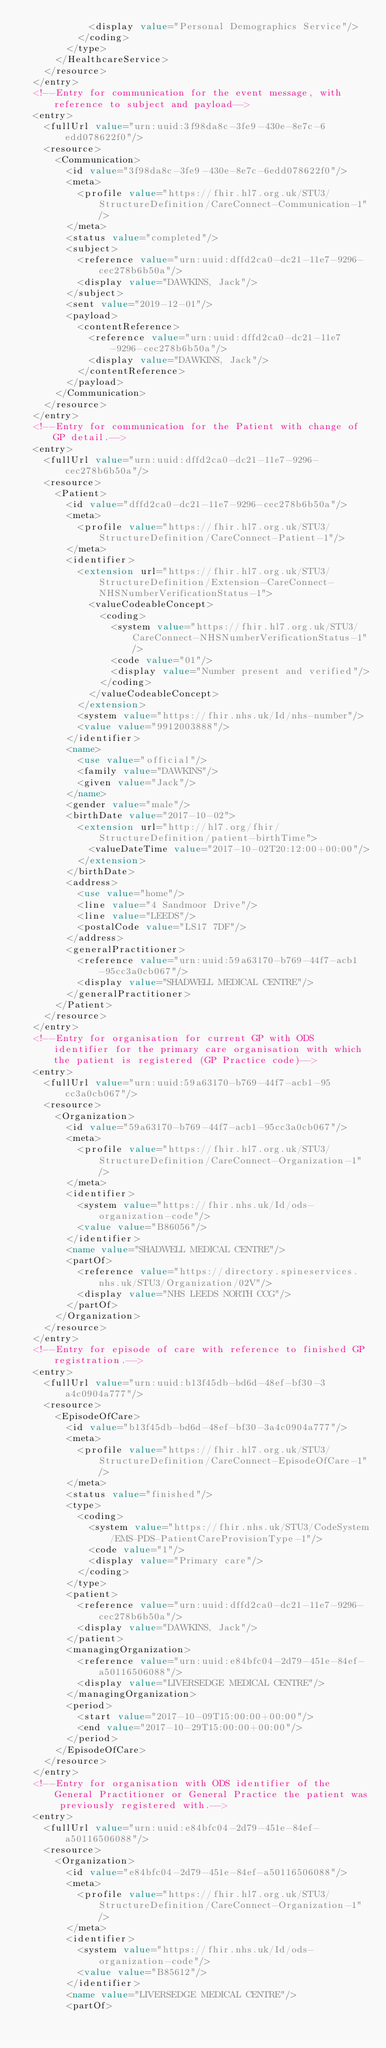Convert code to text. <code><loc_0><loc_0><loc_500><loc_500><_XML_>						<display value="Personal Demographics Service"/>
					</coding>
				</type>
			</HealthcareService>
		</resource>
	</entry>
	<!--Entry for communication for the event message, with reference to subject and payload-->
	<entry>
		<fullUrl value="urn:uuid:3f98da8c-3fe9-430e-8e7c-6edd078622f0"/>
		<resource>
			<Communication>
				<id value="3f98da8c-3fe9-430e-8e7c-6edd078622f0"/>
				<meta>
					<profile value="https://fhir.hl7.org.uk/STU3/StructureDefinition/CareConnect-Communication-1"/>
				</meta>
				<status value="completed"/>
				<subject>
					<reference value="urn:uuid:dffd2ca0-dc21-11e7-9296-cec278b6b50a"/>
					<display value="DAWKINS, Jack"/>
				</subject>
				<sent value="2019-12-01"/>
				<payload>
					<contentReference>
						<reference value="urn:uuid:dffd2ca0-dc21-11e7-9296-cec278b6b50a"/>
						<display value="DAWKINS, Jack"/>
					</contentReference>
				</payload>
			</Communication>
		</resource>
	</entry>
	<!--Entry for communication for the Patient with change of GP detail.-->
	<entry>
		<fullUrl value="urn:uuid:dffd2ca0-dc21-11e7-9296-cec278b6b50a"/>
		<resource>
			<Patient>
				<id value="dffd2ca0-dc21-11e7-9296-cec278b6b50a"/>
				<meta>
					<profile value="https://fhir.hl7.org.uk/STU3/StructureDefinition/CareConnect-Patient-1"/>
				</meta>
				<identifier>
					<extension url="https://fhir.hl7.org.uk/STU3/StructureDefinition/Extension-CareConnect-NHSNumberVerificationStatus-1">
						<valueCodeableConcept>
							<coding>
								<system value="https://fhir.hl7.org.uk/STU3/CareConnect-NHSNumberVerificationStatus-1"/>
								<code value="01"/>
								<display value="Number present and verified"/>
							</coding>
						</valueCodeableConcept>
					</extension>
					<system value="https://fhir.nhs.uk/Id/nhs-number"/>
					<value value="9912003888"/>
				</identifier>
				<name>
					<use value="official"/>
					<family value="DAWKINS"/>
					<given value="Jack"/>
				</name>
				<gender value="male"/>
				<birthDate value="2017-10-02">
					<extension url="http://hl7.org/fhir/StructureDefinition/patient-birthTime">
						<valueDateTime value="2017-10-02T20:12:00+00:00"/>
					</extension>
				</birthDate>
				<address>
					<use value="home"/>
					<line value="4 Sandmoor Drive"/>
					<line value="LEEDS"/>
					<postalCode value="LS17 7DF"/>
				</address>
				<generalPractitioner>
					<reference value="urn:uuid:59a63170-b769-44f7-acb1-95cc3a0cb067"/>
					<display value="SHADWELL MEDICAL CENTRE"/>
				</generalPractitioner>
			</Patient>
		</resource>
	</entry>
	<!--Entry for organisation for current GP with ODS identifier for the primary care organisation with which the patient is registered (GP Practice code)-->
	<entry>
		<fullUrl value="urn:uuid:59a63170-b769-44f7-acb1-95cc3a0cb067"/>
		<resource>
			<Organization>
				<id value="59a63170-b769-44f7-acb1-95cc3a0cb067"/>
				<meta>
					<profile value="https://fhir.hl7.org.uk/STU3/StructureDefinition/CareConnect-Organization-1"/>
				</meta>
				<identifier>
					<system value="https://fhir.nhs.uk/Id/ods-organization-code"/>
					<value value="B86056"/>
				</identifier>
				<name value="SHADWELL MEDICAL CENTRE"/>
				<partOf>
					<reference value="https://directory.spineservices.nhs.uk/STU3/Organization/02V"/>
					<display value="NHS LEEDS NORTH CCG"/>
				</partOf>
			</Organization>
		</resource>
	</entry>
	<!--Entry for episode of care with reference to finished GP registration.-->
	<entry>
		<fullUrl value="urn:uuid:b13f45db-bd6d-48ef-bf30-3a4c0904a777"/>
		<resource>
			<EpisodeOfCare>
				<id value="b13f45db-bd6d-48ef-bf30-3a4c0904a777"/>
				<meta>
					<profile value="https://fhir.hl7.org.uk/STU3/StructureDefinition/CareConnect-EpisodeOfCare-1"/>
				</meta>
				<status value="finished"/>
				<type>
					<coding>
						<system value="https://fhir.nhs.uk/STU3/CodeSystem/EMS-PDS-PatientCareProvisionType-1"/>
						<code value="1"/>
						<display value="Primary care"/>
					</coding>
				</type>
				<patient>
					<reference value="urn:uuid:dffd2ca0-dc21-11e7-9296-cec278b6b50a"/>
					<display value="DAWKINS, Jack"/>
				</patient>
				<managingOrganization>
					<reference value="urn:uuid:e84bfc04-2d79-451e-84ef-a50116506088"/>
					<display value="LIVERSEDGE MEDICAL CENTRE"/>
				</managingOrganization>
				<period>
					<start value="2017-10-09T15:00:00+00:00"/>
					<end value="2017-10-29T15:00:00+00:00"/>
				</period>
			</EpisodeOfCare>
		</resource>
	</entry>
	<!--Entry for organisation with ODS identifier of the General Practitioner or General Practice the patient was previously registered with.-->
	<entry>
		<fullUrl value="urn:uuid:e84bfc04-2d79-451e-84ef-a50116506088"/>
		<resource>
			<Organization>
				<id value="e84bfc04-2d79-451e-84ef-a50116506088"/>
				<meta>
					<profile value="https://fhir.hl7.org.uk/STU3/StructureDefinition/CareConnect-Organization-1"/>
				</meta>
				<identifier>
					<system value="https://fhir.nhs.uk/Id/ods-organization-code"/>
					<value value="B85612"/>
				</identifier>
				<name value="LIVERSEDGE MEDICAL CENTRE"/>
				<partOf></code> 